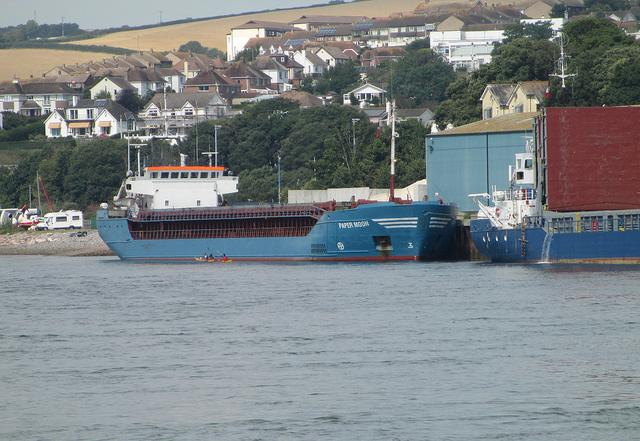What might live in this environment? Please explain your reasoning. fish. This is a water area.  sea creatures would live here. 